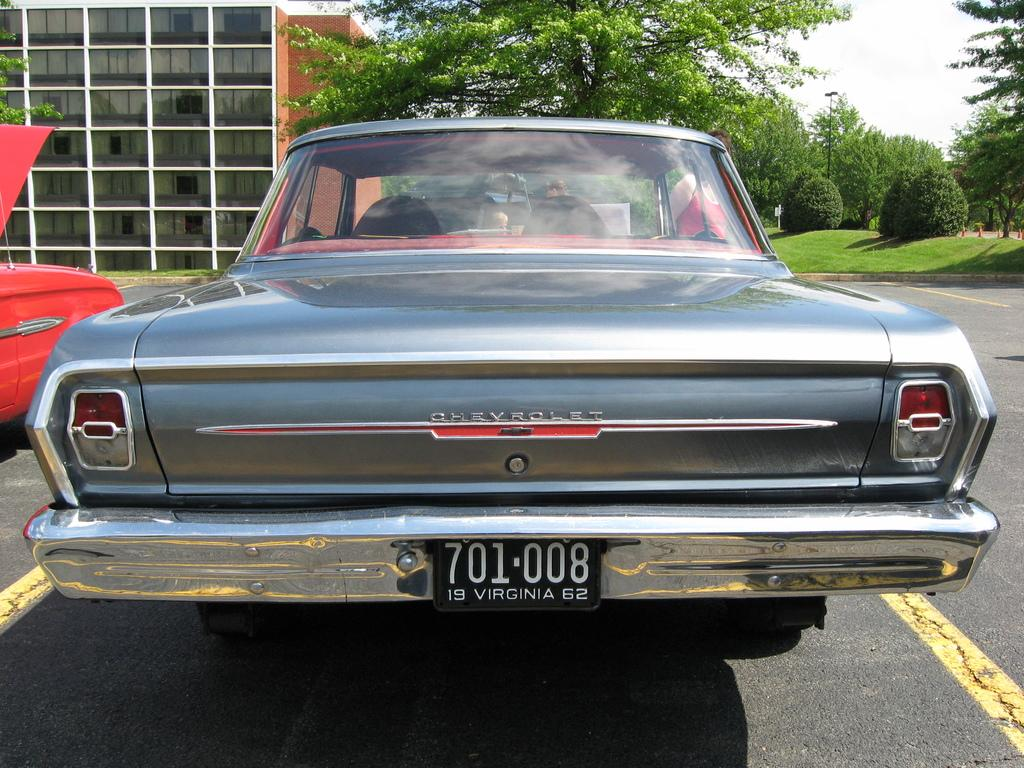What can be seen on the road in the image? There are vehicles on the road in the image. What is visible in the background of the image? There is a building, trees, plants, grass, a pole, and the sky visible in the background. How many different types of vegetation can be seen in the background? There are three types of vegetation visible in the background: trees, plants, and grass. What type of jar is being used to blow bubbles in the image? There is no jar or bubbles present in the image. 